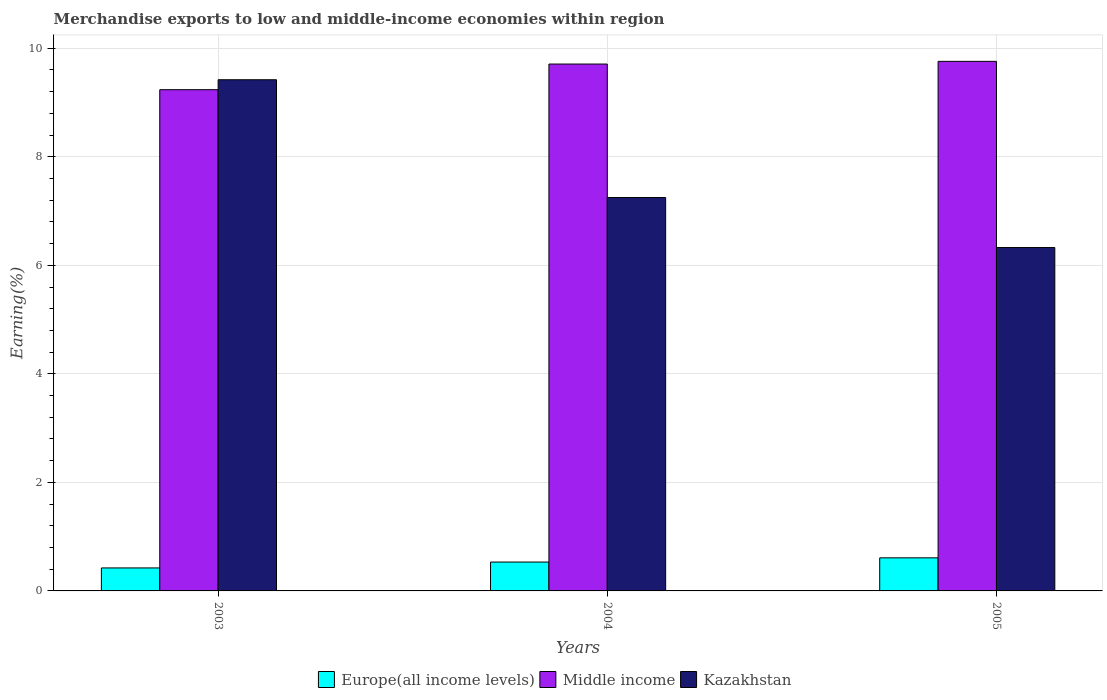Are the number of bars per tick equal to the number of legend labels?
Keep it short and to the point. Yes. What is the percentage of amount earned from merchandise exports in Kazakhstan in 2005?
Give a very brief answer. 6.33. Across all years, what is the maximum percentage of amount earned from merchandise exports in Kazakhstan?
Provide a short and direct response. 9.42. Across all years, what is the minimum percentage of amount earned from merchandise exports in Kazakhstan?
Provide a short and direct response. 6.33. In which year was the percentage of amount earned from merchandise exports in Kazakhstan maximum?
Provide a short and direct response. 2003. In which year was the percentage of amount earned from merchandise exports in Middle income minimum?
Make the answer very short. 2003. What is the total percentage of amount earned from merchandise exports in Kazakhstan in the graph?
Your answer should be very brief. 23. What is the difference between the percentage of amount earned from merchandise exports in Kazakhstan in 2003 and that in 2004?
Ensure brevity in your answer.  2.17. What is the difference between the percentage of amount earned from merchandise exports in Kazakhstan in 2003 and the percentage of amount earned from merchandise exports in Middle income in 2004?
Ensure brevity in your answer.  -0.29. What is the average percentage of amount earned from merchandise exports in Middle income per year?
Provide a succinct answer. 9.57. In the year 2004, what is the difference between the percentage of amount earned from merchandise exports in Kazakhstan and percentage of amount earned from merchandise exports in Europe(all income levels)?
Your answer should be very brief. 6.72. What is the ratio of the percentage of amount earned from merchandise exports in Kazakhstan in 2003 to that in 2005?
Keep it short and to the point. 1.49. Is the percentage of amount earned from merchandise exports in Europe(all income levels) in 2004 less than that in 2005?
Offer a terse response. Yes. Is the difference between the percentage of amount earned from merchandise exports in Kazakhstan in 2004 and 2005 greater than the difference between the percentage of amount earned from merchandise exports in Europe(all income levels) in 2004 and 2005?
Provide a succinct answer. Yes. What is the difference between the highest and the second highest percentage of amount earned from merchandise exports in Kazakhstan?
Your answer should be compact. 2.17. What is the difference between the highest and the lowest percentage of amount earned from merchandise exports in Middle income?
Give a very brief answer. 0.52. In how many years, is the percentage of amount earned from merchandise exports in Europe(all income levels) greater than the average percentage of amount earned from merchandise exports in Europe(all income levels) taken over all years?
Your answer should be compact. 2. What does the 3rd bar from the right in 2003 represents?
Provide a short and direct response. Europe(all income levels). How many years are there in the graph?
Keep it short and to the point. 3. What is the difference between two consecutive major ticks on the Y-axis?
Offer a terse response. 2. Does the graph contain any zero values?
Offer a terse response. No. Does the graph contain grids?
Provide a short and direct response. Yes. Where does the legend appear in the graph?
Make the answer very short. Bottom center. How are the legend labels stacked?
Your response must be concise. Horizontal. What is the title of the graph?
Make the answer very short. Merchandise exports to low and middle-income economies within region. What is the label or title of the Y-axis?
Offer a very short reply. Earning(%). What is the Earning(%) in Europe(all income levels) in 2003?
Provide a succinct answer. 0.42. What is the Earning(%) in Middle income in 2003?
Give a very brief answer. 9.24. What is the Earning(%) of Kazakhstan in 2003?
Your answer should be compact. 9.42. What is the Earning(%) in Europe(all income levels) in 2004?
Provide a succinct answer. 0.53. What is the Earning(%) in Middle income in 2004?
Offer a terse response. 9.71. What is the Earning(%) of Kazakhstan in 2004?
Your answer should be very brief. 7.25. What is the Earning(%) of Europe(all income levels) in 2005?
Keep it short and to the point. 0.61. What is the Earning(%) in Middle income in 2005?
Your answer should be compact. 9.76. What is the Earning(%) in Kazakhstan in 2005?
Offer a very short reply. 6.33. Across all years, what is the maximum Earning(%) in Europe(all income levels)?
Offer a very short reply. 0.61. Across all years, what is the maximum Earning(%) in Middle income?
Offer a very short reply. 9.76. Across all years, what is the maximum Earning(%) in Kazakhstan?
Your answer should be compact. 9.42. Across all years, what is the minimum Earning(%) of Europe(all income levels)?
Your answer should be compact. 0.42. Across all years, what is the minimum Earning(%) in Middle income?
Ensure brevity in your answer.  9.24. Across all years, what is the minimum Earning(%) of Kazakhstan?
Your answer should be very brief. 6.33. What is the total Earning(%) of Europe(all income levels) in the graph?
Offer a terse response. 1.57. What is the total Earning(%) in Middle income in the graph?
Provide a succinct answer. 28.7. What is the total Earning(%) of Kazakhstan in the graph?
Provide a short and direct response. 23. What is the difference between the Earning(%) of Europe(all income levels) in 2003 and that in 2004?
Offer a very short reply. -0.11. What is the difference between the Earning(%) in Middle income in 2003 and that in 2004?
Ensure brevity in your answer.  -0.47. What is the difference between the Earning(%) of Kazakhstan in 2003 and that in 2004?
Offer a terse response. 2.17. What is the difference between the Earning(%) of Europe(all income levels) in 2003 and that in 2005?
Make the answer very short. -0.19. What is the difference between the Earning(%) of Middle income in 2003 and that in 2005?
Your answer should be compact. -0.52. What is the difference between the Earning(%) of Kazakhstan in 2003 and that in 2005?
Your response must be concise. 3.09. What is the difference between the Earning(%) in Europe(all income levels) in 2004 and that in 2005?
Provide a succinct answer. -0.08. What is the difference between the Earning(%) in Middle income in 2004 and that in 2005?
Provide a short and direct response. -0.05. What is the difference between the Earning(%) in Kazakhstan in 2004 and that in 2005?
Your response must be concise. 0.92. What is the difference between the Earning(%) of Europe(all income levels) in 2003 and the Earning(%) of Middle income in 2004?
Ensure brevity in your answer.  -9.29. What is the difference between the Earning(%) in Europe(all income levels) in 2003 and the Earning(%) in Kazakhstan in 2004?
Provide a short and direct response. -6.83. What is the difference between the Earning(%) in Middle income in 2003 and the Earning(%) in Kazakhstan in 2004?
Provide a succinct answer. 1.99. What is the difference between the Earning(%) of Europe(all income levels) in 2003 and the Earning(%) of Middle income in 2005?
Offer a very short reply. -9.33. What is the difference between the Earning(%) in Europe(all income levels) in 2003 and the Earning(%) in Kazakhstan in 2005?
Your response must be concise. -5.9. What is the difference between the Earning(%) in Middle income in 2003 and the Earning(%) in Kazakhstan in 2005?
Give a very brief answer. 2.91. What is the difference between the Earning(%) of Europe(all income levels) in 2004 and the Earning(%) of Middle income in 2005?
Your answer should be very brief. -9.23. What is the difference between the Earning(%) of Europe(all income levels) in 2004 and the Earning(%) of Kazakhstan in 2005?
Ensure brevity in your answer.  -5.8. What is the difference between the Earning(%) of Middle income in 2004 and the Earning(%) of Kazakhstan in 2005?
Provide a short and direct response. 3.38. What is the average Earning(%) of Europe(all income levels) per year?
Your response must be concise. 0.52. What is the average Earning(%) in Middle income per year?
Make the answer very short. 9.57. What is the average Earning(%) in Kazakhstan per year?
Offer a terse response. 7.67. In the year 2003, what is the difference between the Earning(%) in Europe(all income levels) and Earning(%) in Middle income?
Offer a terse response. -8.81. In the year 2003, what is the difference between the Earning(%) of Europe(all income levels) and Earning(%) of Kazakhstan?
Give a very brief answer. -9. In the year 2003, what is the difference between the Earning(%) of Middle income and Earning(%) of Kazakhstan?
Offer a terse response. -0.18. In the year 2004, what is the difference between the Earning(%) of Europe(all income levels) and Earning(%) of Middle income?
Offer a terse response. -9.18. In the year 2004, what is the difference between the Earning(%) of Europe(all income levels) and Earning(%) of Kazakhstan?
Offer a terse response. -6.72. In the year 2004, what is the difference between the Earning(%) of Middle income and Earning(%) of Kazakhstan?
Keep it short and to the point. 2.46. In the year 2005, what is the difference between the Earning(%) of Europe(all income levels) and Earning(%) of Middle income?
Offer a very short reply. -9.15. In the year 2005, what is the difference between the Earning(%) in Europe(all income levels) and Earning(%) in Kazakhstan?
Give a very brief answer. -5.72. In the year 2005, what is the difference between the Earning(%) in Middle income and Earning(%) in Kazakhstan?
Your response must be concise. 3.43. What is the ratio of the Earning(%) of Europe(all income levels) in 2003 to that in 2004?
Offer a terse response. 0.8. What is the ratio of the Earning(%) of Middle income in 2003 to that in 2004?
Offer a very short reply. 0.95. What is the ratio of the Earning(%) in Kazakhstan in 2003 to that in 2004?
Your answer should be very brief. 1.3. What is the ratio of the Earning(%) of Europe(all income levels) in 2003 to that in 2005?
Your answer should be very brief. 0.7. What is the ratio of the Earning(%) in Middle income in 2003 to that in 2005?
Keep it short and to the point. 0.95. What is the ratio of the Earning(%) in Kazakhstan in 2003 to that in 2005?
Your response must be concise. 1.49. What is the ratio of the Earning(%) of Europe(all income levels) in 2004 to that in 2005?
Keep it short and to the point. 0.87. What is the ratio of the Earning(%) in Kazakhstan in 2004 to that in 2005?
Offer a very short reply. 1.15. What is the difference between the highest and the second highest Earning(%) in Europe(all income levels)?
Make the answer very short. 0.08. What is the difference between the highest and the second highest Earning(%) in Middle income?
Offer a very short reply. 0.05. What is the difference between the highest and the second highest Earning(%) of Kazakhstan?
Provide a succinct answer. 2.17. What is the difference between the highest and the lowest Earning(%) of Europe(all income levels)?
Give a very brief answer. 0.19. What is the difference between the highest and the lowest Earning(%) of Middle income?
Your answer should be very brief. 0.52. What is the difference between the highest and the lowest Earning(%) of Kazakhstan?
Ensure brevity in your answer.  3.09. 